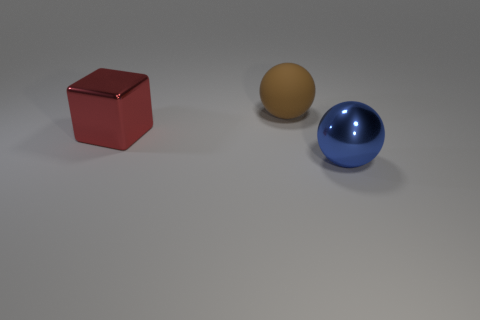There is a large object that is on the right side of the red thing and in front of the big brown matte sphere; what is it made of?
Provide a short and direct response. Metal. Is the color of the large cube the same as the big sphere in front of the metallic block?
Keep it short and to the point. No. What material is the blue object that is the same size as the brown sphere?
Your response must be concise. Metal. Is there another ball that has the same material as the brown ball?
Give a very brief answer. No. How many large purple cylinders are there?
Provide a succinct answer. 0. Is the material of the big red block the same as the brown sphere behind the large blue metal object?
Give a very brief answer. No. How many blocks are the same color as the shiny sphere?
Give a very brief answer. 0. How big is the blue metallic sphere?
Ensure brevity in your answer.  Large. Is the shape of the red thing the same as the metallic thing on the right side of the large brown thing?
Your answer should be very brief. No. There is a ball that is made of the same material as the big red thing; what is its color?
Your response must be concise. Blue. 